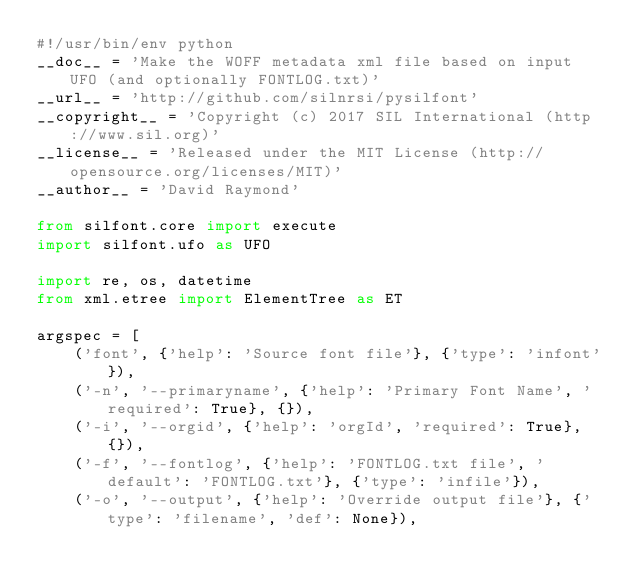<code> <loc_0><loc_0><loc_500><loc_500><_Python_>#!/usr/bin/env python
__doc__ = 'Make the WOFF metadata xml file based on input UFO (and optionally FONTLOG.txt)'
__url__ = 'http://github.com/silnrsi/pysilfont'
__copyright__ = 'Copyright (c) 2017 SIL International (http://www.sil.org)'
__license__ = 'Released under the MIT License (http://opensource.org/licenses/MIT)'
__author__ = 'David Raymond'

from silfont.core import execute
import silfont.ufo as UFO

import re, os, datetime
from xml.etree import ElementTree as ET

argspec = [
    ('font', {'help': 'Source font file'}, {'type': 'infont'}),
    ('-n', '--primaryname', {'help': 'Primary Font Name', 'required': True}, {}),
    ('-i', '--orgid', {'help': 'orgId', 'required': True}, {}),
    ('-f', '--fontlog', {'help': 'FONTLOG.txt file', 'default': 'FONTLOG.txt'}, {'type': 'infile'}),
    ('-o', '--output', {'help': 'Override output file'}, {'type': 'filename', 'def': None}),</code> 